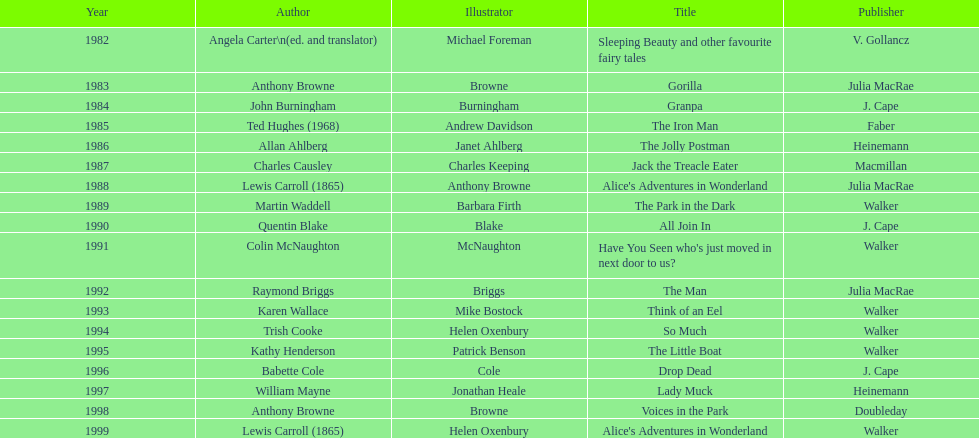Other than lewis carroll, which alternate writer has been victorious in the kurt maschler award twice? Anthony Browne. 